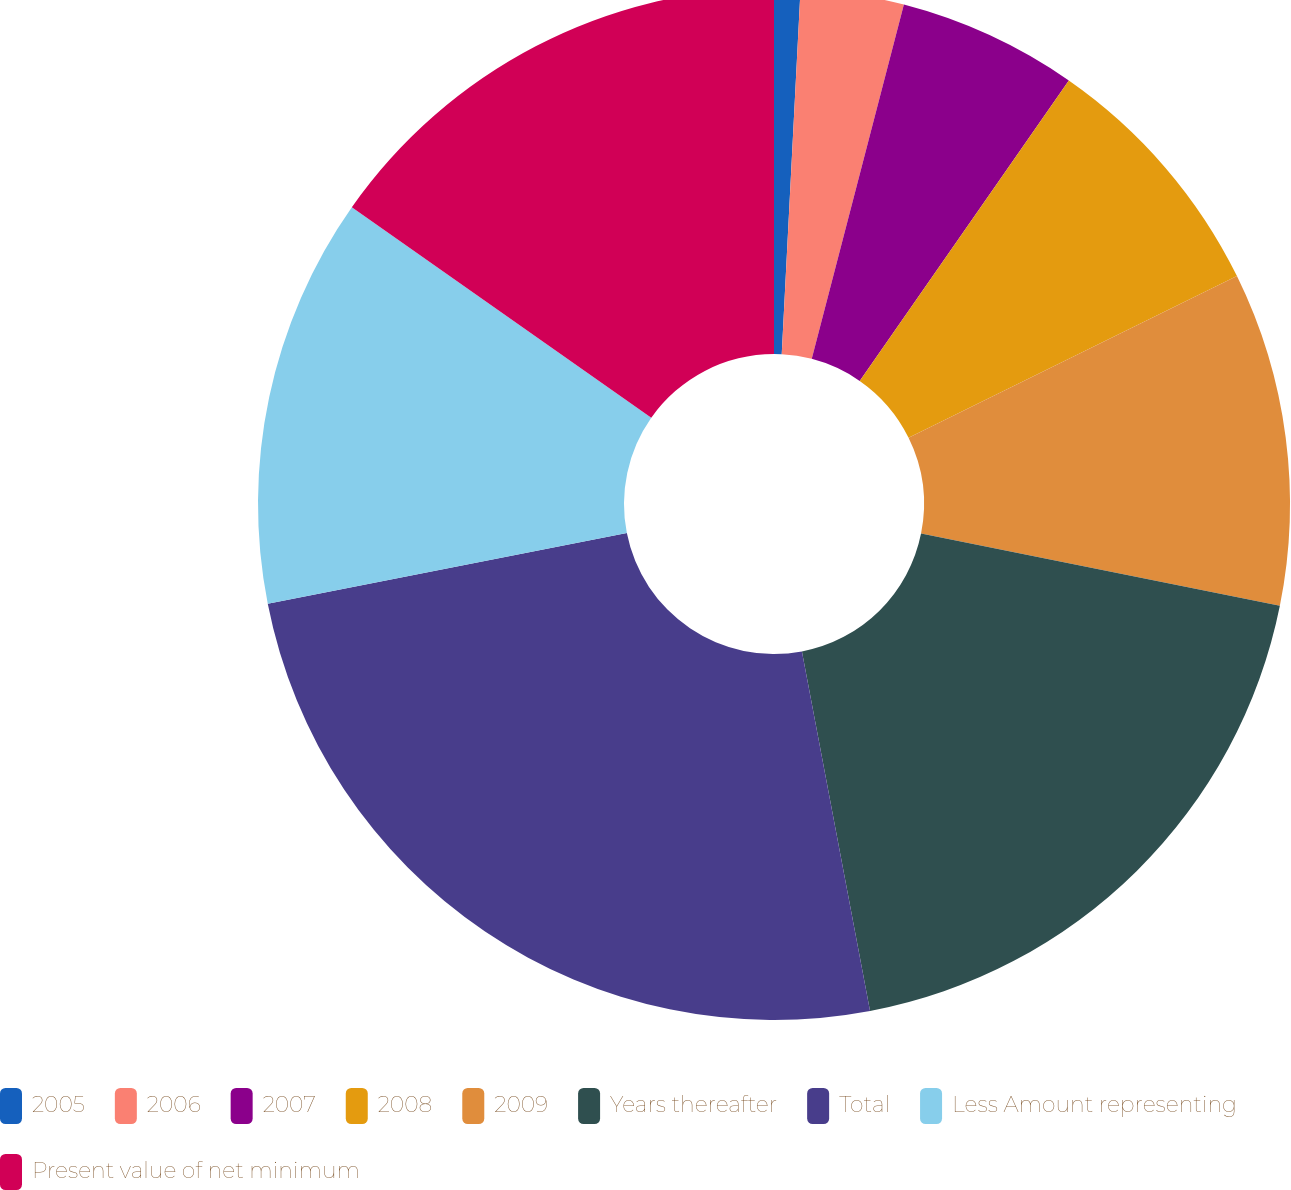<chart> <loc_0><loc_0><loc_500><loc_500><pie_chart><fcel>2005<fcel>2006<fcel>2007<fcel>2008<fcel>2009<fcel>Years thereafter<fcel>Total<fcel>Less Amount representing<fcel>Present value of net minimum<nl><fcel>0.82%<fcel>3.23%<fcel>5.63%<fcel>8.04%<fcel>10.44%<fcel>18.86%<fcel>24.88%<fcel>12.85%<fcel>15.25%<nl></chart> 